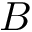Convert formula to latex. <formula><loc_0><loc_0><loc_500><loc_500>B</formula> 